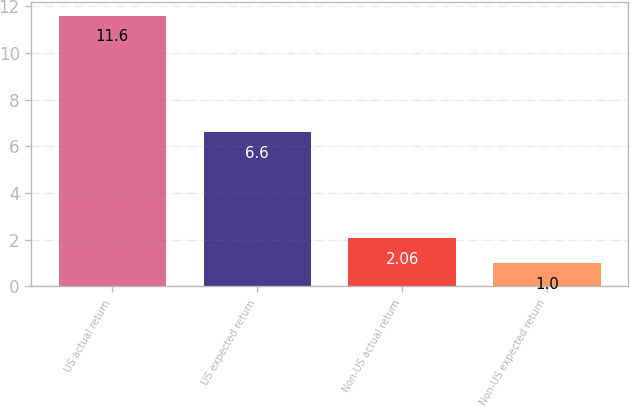<chart> <loc_0><loc_0><loc_500><loc_500><bar_chart><fcel>US actual return<fcel>US expected return<fcel>Non-US actual return<fcel>Non-US expected return<nl><fcel>11.6<fcel>6.6<fcel>2.06<fcel>1<nl></chart> 